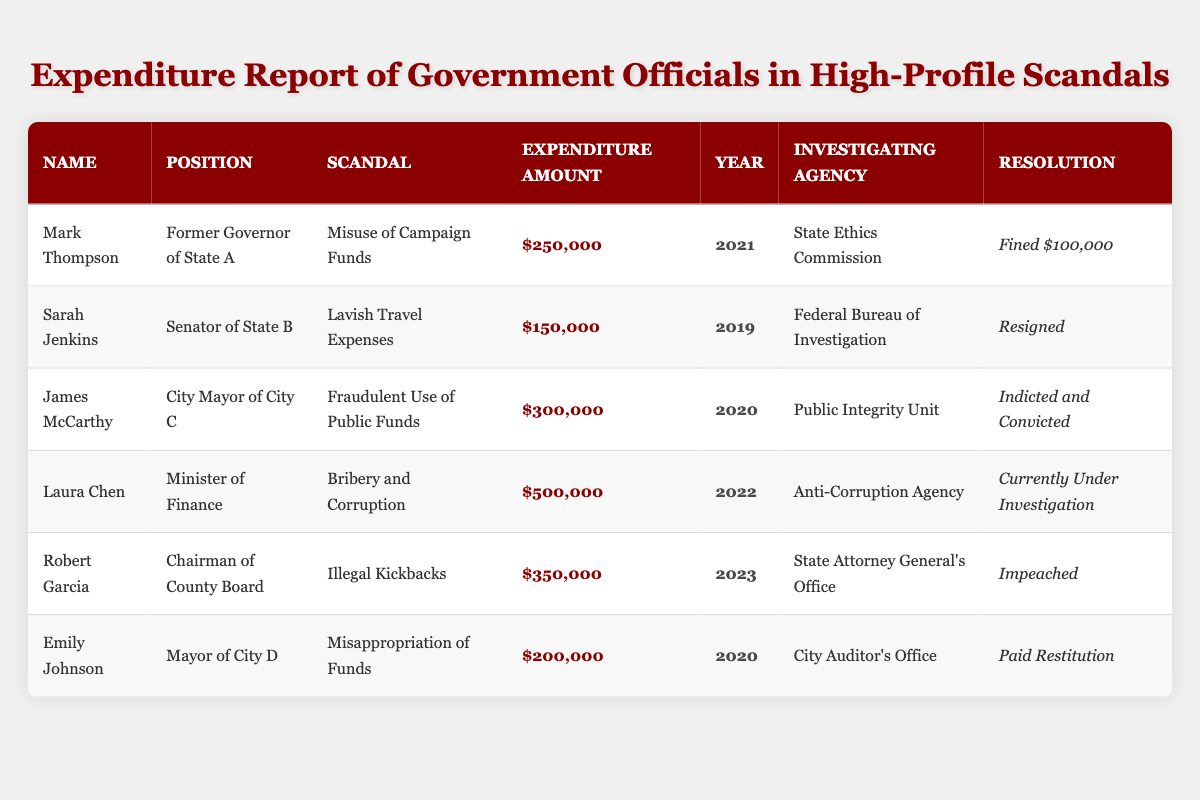What is the largest expenditure amount recorded in the table? The table lists various expenditure amounts, and the largest amount is $500,000, which belongs to Laura Chen, the Minister of Finance.
Answer: $500,000 Who was fined $100,000? Mark Thompson, the Former Governor of State A, was fined $100,000 for the misuse of campaign funds.
Answer: Mark Thompson How many officials were involved in scandals related to the year 2020? In 2020, there are two officials listed: James McCarthy and Emily Johnson.
Answer: 2 What is the resolution for Laura Chen's case? Laura Chen's case is currently under investigation as listed in the table.
Answer: Currently Under Investigation Which scandal involved the highest expenditure? The Bribery and Corruption scandal involving Laura Chen had the highest expenditure amount of $500,000.
Answer: Bribery and Corruption Did Sarah Jenkins resign following her scandal? Yes, the table indicates that Sarah Jenkins resigned due to her involvement in lavish travel expenses.
Answer: Yes What is the average expenditure amount for the officials listed in the report? The total expenditure amounts are $250,000 + $150,000 + $300,000 + $500,000 + $350,000 + $200,000 = $1,750,000. There are 6 entries, so the average is $1,750,000 / 6 = approximately $291,667.
Answer: $291,667 Which investigating agency looked into the Illegal Kickbacks scandal? The Illegal Kickbacks scandal involving Robert Garcia was investigated by the State Attorney General's Office.
Answer: State Attorney General's Office How many different scandals are represented in the table? The table presents six distinct scandals involving various officials.
Answer: 6 What is the position of the official with the second-highest expenditure amount? Laura Chen, who is the Minister of Finance, has the second-highest expenditure amount, which is $500,000.
Answer: Minister of Finance In how many cases did the resolutions involve legal action (e.g., indicted, impeached)? There are three cases with resolutions involving legal actions: James McCarthy (Indicted and Convicted), Robert Garcia (Impeached), and Laura Chen (Currently Under Investigation).
Answer: 3 